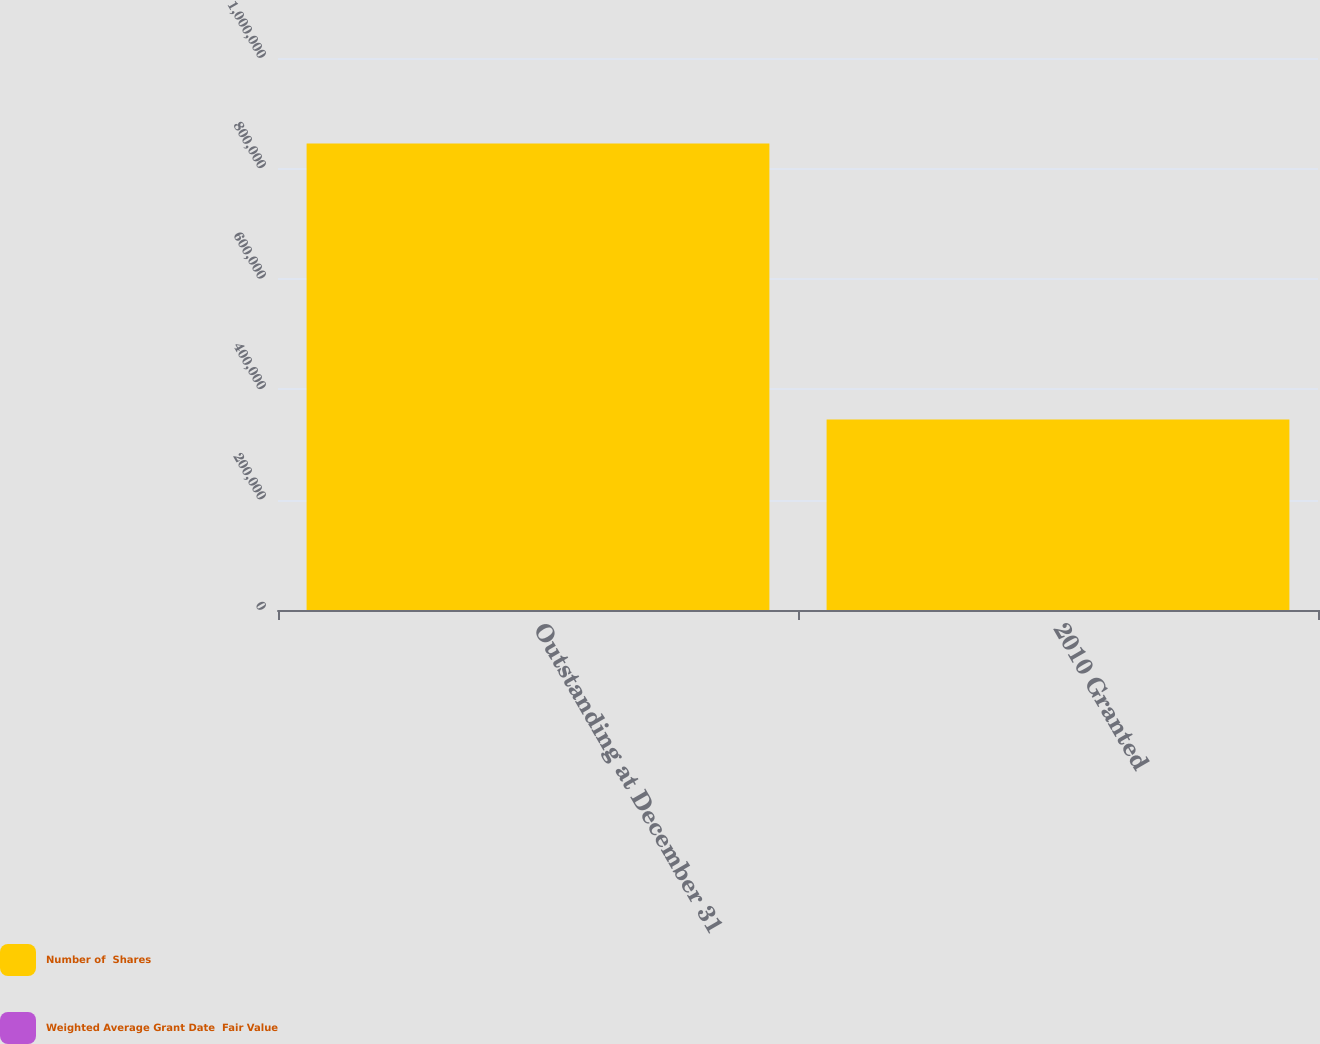Convert chart to OTSL. <chart><loc_0><loc_0><loc_500><loc_500><stacked_bar_chart><ecel><fcel>Outstanding at December 31<fcel>2010 Granted<nl><fcel>Number of  Shares<fcel>845000<fcel>345000<nl><fcel>Weighted Average Grant Date  Fair Value<fcel>25.37<fcel>30.37<nl></chart> 